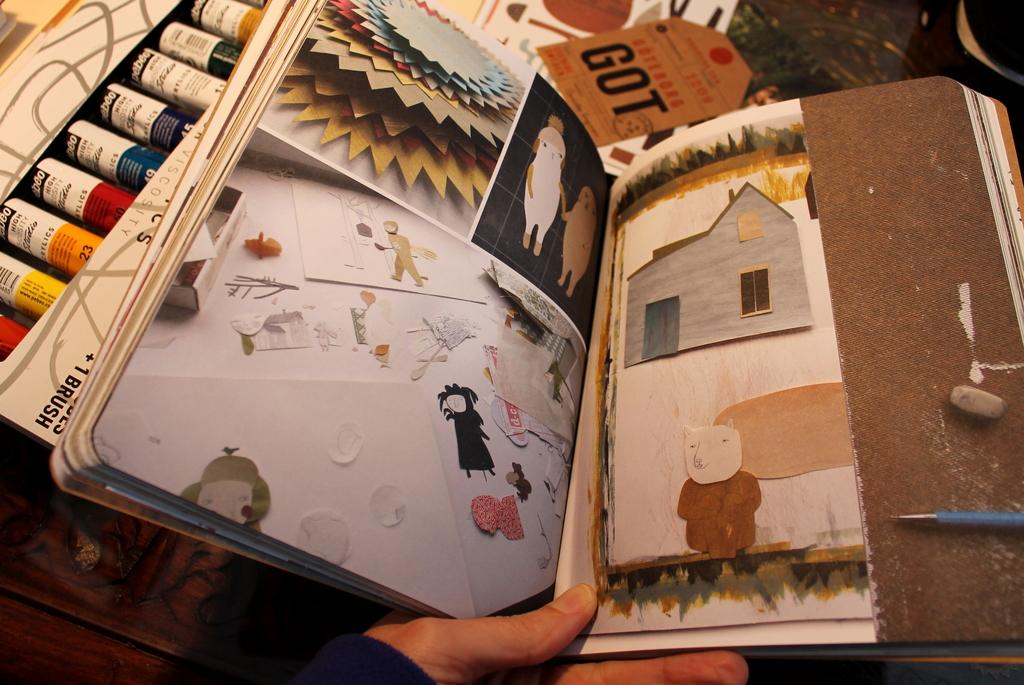<image>
Offer a succinct explanation of the picture presented. Book showing drawings and art with a label "GOT" near the top. 